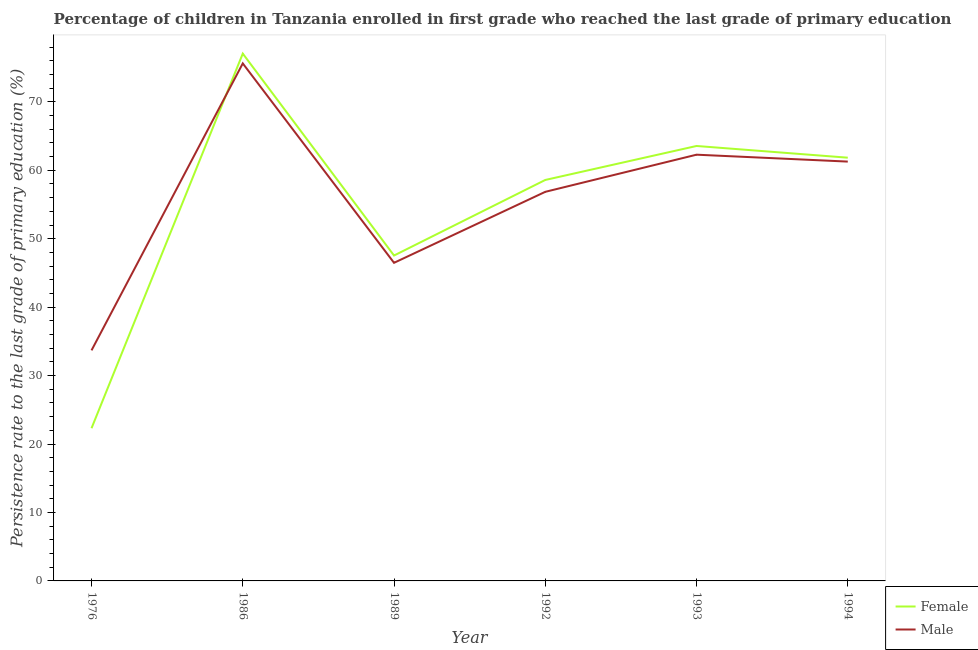Does the line corresponding to persistence rate of male students intersect with the line corresponding to persistence rate of female students?
Your answer should be very brief. Yes. What is the persistence rate of female students in 1976?
Offer a very short reply. 22.31. Across all years, what is the maximum persistence rate of female students?
Your answer should be compact. 77.05. Across all years, what is the minimum persistence rate of female students?
Offer a very short reply. 22.31. In which year was the persistence rate of female students maximum?
Offer a very short reply. 1986. In which year was the persistence rate of male students minimum?
Your answer should be compact. 1976. What is the total persistence rate of female students in the graph?
Offer a very short reply. 330.88. What is the difference between the persistence rate of male students in 1976 and that in 1992?
Provide a succinct answer. -23.16. What is the difference between the persistence rate of male students in 1986 and the persistence rate of female students in 1994?
Your answer should be very brief. 13.77. What is the average persistence rate of female students per year?
Give a very brief answer. 55.15. In the year 1976, what is the difference between the persistence rate of male students and persistence rate of female students?
Your answer should be compact. 11.38. In how many years, is the persistence rate of female students greater than 30 %?
Offer a terse response. 5. What is the ratio of the persistence rate of female students in 1986 to that in 1992?
Offer a very short reply. 1.32. Is the persistence rate of male students in 1986 less than that in 1992?
Keep it short and to the point. No. What is the difference between the highest and the second highest persistence rate of male students?
Make the answer very short. 13.34. What is the difference between the highest and the lowest persistence rate of female students?
Provide a short and direct response. 54.74. In how many years, is the persistence rate of male students greater than the average persistence rate of male students taken over all years?
Ensure brevity in your answer.  4. Is the sum of the persistence rate of male students in 1993 and 1994 greater than the maximum persistence rate of female students across all years?
Your answer should be compact. Yes. Is the persistence rate of female students strictly greater than the persistence rate of male students over the years?
Offer a terse response. No. How many lines are there?
Provide a succinct answer. 2. What is the difference between two consecutive major ticks on the Y-axis?
Your answer should be compact. 10. Are the values on the major ticks of Y-axis written in scientific E-notation?
Provide a succinct answer. No. Does the graph contain grids?
Ensure brevity in your answer.  No. Where does the legend appear in the graph?
Ensure brevity in your answer.  Bottom right. How are the legend labels stacked?
Offer a terse response. Vertical. What is the title of the graph?
Give a very brief answer. Percentage of children in Tanzania enrolled in first grade who reached the last grade of primary education. What is the label or title of the X-axis?
Provide a succinct answer. Year. What is the label or title of the Y-axis?
Give a very brief answer. Persistence rate to the last grade of primary education (%). What is the Persistence rate to the last grade of primary education (%) in Female in 1976?
Provide a short and direct response. 22.31. What is the Persistence rate to the last grade of primary education (%) in Male in 1976?
Provide a short and direct response. 33.69. What is the Persistence rate to the last grade of primary education (%) in Female in 1986?
Ensure brevity in your answer.  77.05. What is the Persistence rate to the last grade of primary education (%) of Male in 1986?
Offer a very short reply. 75.62. What is the Persistence rate to the last grade of primary education (%) in Female in 1989?
Provide a short and direct response. 47.55. What is the Persistence rate to the last grade of primary education (%) in Male in 1989?
Ensure brevity in your answer.  46.48. What is the Persistence rate to the last grade of primary education (%) in Female in 1992?
Provide a short and direct response. 58.59. What is the Persistence rate to the last grade of primary education (%) in Male in 1992?
Your response must be concise. 56.85. What is the Persistence rate to the last grade of primary education (%) of Female in 1993?
Ensure brevity in your answer.  63.55. What is the Persistence rate to the last grade of primary education (%) in Male in 1993?
Make the answer very short. 62.28. What is the Persistence rate to the last grade of primary education (%) in Female in 1994?
Make the answer very short. 61.84. What is the Persistence rate to the last grade of primary education (%) in Male in 1994?
Your response must be concise. 61.27. Across all years, what is the maximum Persistence rate to the last grade of primary education (%) in Female?
Give a very brief answer. 77.05. Across all years, what is the maximum Persistence rate to the last grade of primary education (%) of Male?
Provide a short and direct response. 75.62. Across all years, what is the minimum Persistence rate to the last grade of primary education (%) in Female?
Ensure brevity in your answer.  22.31. Across all years, what is the minimum Persistence rate to the last grade of primary education (%) of Male?
Give a very brief answer. 33.69. What is the total Persistence rate to the last grade of primary education (%) of Female in the graph?
Your answer should be very brief. 330.88. What is the total Persistence rate to the last grade of primary education (%) of Male in the graph?
Your answer should be very brief. 336.19. What is the difference between the Persistence rate to the last grade of primary education (%) in Female in 1976 and that in 1986?
Ensure brevity in your answer.  -54.74. What is the difference between the Persistence rate to the last grade of primary education (%) of Male in 1976 and that in 1986?
Your answer should be very brief. -41.93. What is the difference between the Persistence rate to the last grade of primary education (%) of Female in 1976 and that in 1989?
Your answer should be compact. -25.23. What is the difference between the Persistence rate to the last grade of primary education (%) of Male in 1976 and that in 1989?
Offer a very short reply. -12.79. What is the difference between the Persistence rate to the last grade of primary education (%) in Female in 1976 and that in 1992?
Your answer should be compact. -36.27. What is the difference between the Persistence rate to the last grade of primary education (%) of Male in 1976 and that in 1992?
Offer a terse response. -23.16. What is the difference between the Persistence rate to the last grade of primary education (%) in Female in 1976 and that in 1993?
Your response must be concise. -41.24. What is the difference between the Persistence rate to the last grade of primary education (%) of Male in 1976 and that in 1993?
Give a very brief answer. -28.59. What is the difference between the Persistence rate to the last grade of primary education (%) of Female in 1976 and that in 1994?
Keep it short and to the point. -39.53. What is the difference between the Persistence rate to the last grade of primary education (%) in Male in 1976 and that in 1994?
Give a very brief answer. -27.58. What is the difference between the Persistence rate to the last grade of primary education (%) in Female in 1986 and that in 1989?
Keep it short and to the point. 29.5. What is the difference between the Persistence rate to the last grade of primary education (%) in Male in 1986 and that in 1989?
Your answer should be very brief. 29.14. What is the difference between the Persistence rate to the last grade of primary education (%) of Female in 1986 and that in 1992?
Offer a terse response. 18.46. What is the difference between the Persistence rate to the last grade of primary education (%) of Male in 1986 and that in 1992?
Keep it short and to the point. 18.76. What is the difference between the Persistence rate to the last grade of primary education (%) of Female in 1986 and that in 1993?
Your answer should be very brief. 13.5. What is the difference between the Persistence rate to the last grade of primary education (%) in Male in 1986 and that in 1993?
Provide a succinct answer. 13.34. What is the difference between the Persistence rate to the last grade of primary education (%) of Female in 1986 and that in 1994?
Give a very brief answer. 15.21. What is the difference between the Persistence rate to the last grade of primary education (%) in Male in 1986 and that in 1994?
Give a very brief answer. 14.35. What is the difference between the Persistence rate to the last grade of primary education (%) of Female in 1989 and that in 1992?
Provide a short and direct response. -11.04. What is the difference between the Persistence rate to the last grade of primary education (%) in Male in 1989 and that in 1992?
Your answer should be compact. -10.37. What is the difference between the Persistence rate to the last grade of primary education (%) in Female in 1989 and that in 1993?
Your response must be concise. -16.01. What is the difference between the Persistence rate to the last grade of primary education (%) of Male in 1989 and that in 1993?
Provide a succinct answer. -15.8. What is the difference between the Persistence rate to the last grade of primary education (%) of Female in 1989 and that in 1994?
Your answer should be compact. -14.3. What is the difference between the Persistence rate to the last grade of primary education (%) in Male in 1989 and that in 1994?
Give a very brief answer. -14.79. What is the difference between the Persistence rate to the last grade of primary education (%) of Female in 1992 and that in 1993?
Ensure brevity in your answer.  -4.97. What is the difference between the Persistence rate to the last grade of primary education (%) of Male in 1992 and that in 1993?
Ensure brevity in your answer.  -5.43. What is the difference between the Persistence rate to the last grade of primary education (%) in Female in 1992 and that in 1994?
Provide a succinct answer. -3.25. What is the difference between the Persistence rate to the last grade of primary education (%) in Male in 1992 and that in 1994?
Provide a succinct answer. -4.42. What is the difference between the Persistence rate to the last grade of primary education (%) of Female in 1993 and that in 1994?
Offer a very short reply. 1.71. What is the difference between the Persistence rate to the last grade of primary education (%) in Male in 1993 and that in 1994?
Keep it short and to the point. 1.01. What is the difference between the Persistence rate to the last grade of primary education (%) in Female in 1976 and the Persistence rate to the last grade of primary education (%) in Male in 1986?
Ensure brevity in your answer.  -53.3. What is the difference between the Persistence rate to the last grade of primary education (%) in Female in 1976 and the Persistence rate to the last grade of primary education (%) in Male in 1989?
Provide a short and direct response. -24.17. What is the difference between the Persistence rate to the last grade of primary education (%) of Female in 1976 and the Persistence rate to the last grade of primary education (%) of Male in 1992?
Provide a succinct answer. -34.54. What is the difference between the Persistence rate to the last grade of primary education (%) in Female in 1976 and the Persistence rate to the last grade of primary education (%) in Male in 1993?
Make the answer very short. -39.97. What is the difference between the Persistence rate to the last grade of primary education (%) in Female in 1976 and the Persistence rate to the last grade of primary education (%) in Male in 1994?
Make the answer very short. -38.96. What is the difference between the Persistence rate to the last grade of primary education (%) in Female in 1986 and the Persistence rate to the last grade of primary education (%) in Male in 1989?
Provide a succinct answer. 30.57. What is the difference between the Persistence rate to the last grade of primary education (%) of Female in 1986 and the Persistence rate to the last grade of primary education (%) of Male in 1992?
Keep it short and to the point. 20.2. What is the difference between the Persistence rate to the last grade of primary education (%) in Female in 1986 and the Persistence rate to the last grade of primary education (%) in Male in 1993?
Make the answer very short. 14.77. What is the difference between the Persistence rate to the last grade of primary education (%) in Female in 1986 and the Persistence rate to the last grade of primary education (%) in Male in 1994?
Offer a very short reply. 15.78. What is the difference between the Persistence rate to the last grade of primary education (%) in Female in 1989 and the Persistence rate to the last grade of primary education (%) in Male in 1992?
Provide a succinct answer. -9.31. What is the difference between the Persistence rate to the last grade of primary education (%) in Female in 1989 and the Persistence rate to the last grade of primary education (%) in Male in 1993?
Provide a succinct answer. -14.73. What is the difference between the Persistence rate to the last grade of primary education (%) in Female in 1989 and the Persistence rate to the last grade of primary education (%) in Male in 1994?
Provide a succinct answer. -13.72. What is the difference between the Persistence rate to the last grade of primary education (%) in Female in 1992 and the Persistence rate to the last grade of primary education (%) in Male in 1993?
Provide a short and direct response. -3.69. What is the difference between the Persistence rate to the last grade of primary education (%) of Female in 1992 and the Persistence rate to the last grade of primary education (%) of Male in 1994?
Provide a succinct answer. -2.68. What is the difference between the Persistence rate to the last grade of primary education (%) of Female in 1993 and the Persistence rate to the last grade of primary education (%) of Male in 1994?
Make the answer very short. 2.28. What is the average Persistence rate to the last grade of primary education (%) of Female per year?
Your answer should be very brief. 55.15. What is the average Persistence rate to the last grade of primary education (%) of Male per year?
Ensure brevity in your answer.  56.03. In the year 1976, what is the difference between the Persistence rate to the last grade of primary education (%) in Female and Persistence rate to the last grade of primary education (%) in Male?
Offer a very short reply. -11.38. In the year 1986, what is the difference between the Persistence rate to the last grade of primary education (%) in Female and Persistence rate to the last grade of primary education (%) in Male?
Offer a very short reply. 1.43. In the year 1989, what is the difference between the Persistence rate to the last grade of primary education (%) in Female and Persistence rate to the last grade of primary education (%) in Male?
Your answer should be compact. 1.06. In the year 1992, what is the difference between the Persistence rate to the last grade of primary education (%) in Female and Persistence rate to the last grade of primary education (%) in Male?
Your response must be concise. 1.73. In the year 1993, what is the difference between the Persistence rate to the last grade of primary education (%) of Female and Persistence rate to the last grade of primary education (%) of Male?
Your response must be concise. 1.27. In the year 1994, what is the difference between the Persistence rate to the last grade of primary education (%) of Female and Persistence rate to the last grade of primary education (%) of Male?
Keep it short and to the point. 0.57. What is the ratio of the Persistence rate to the last grade of primary education (%) in Female in 1976 to that in 1986?
Give a very brief answer. 0.29. What is the ratio of the Persistence rate to the last grade of primary education (%) in Male in 1976 to that in 1986?
Offer a very short reply. 0.45. What is the ratio of the Persistence rate to the last grade of primary education (%) of Female in 1976 to that in 1989?
Make the answer very short. 0.47. What is the ratio of the Persistence rate to the last grade of primary education (%) of Male in 1976 to that in 1989?
Offer a very short reply. 0.72. What is the ratio of the Persistence rate to the last grade of primary education (%) of Female in 1976 to that in 1992?
Offer a terse response. 0.38. What is the ratio of the Persistence rate to the last grade of primary education (%) of Male in 1976 to that in 1992?
Your answer should be compact. 0.59. What is the ratio of the Persistence rate to the last grade of primary education (%) in Female in 1976 to that in 1993?
Your response must be concise. 0.35. What is the ratio of the Persistence rate to the last grade of primary education (%) of Male in 1976 to that in 1993?
Ensure brevity in your answer.  0.54. What is the ratio of the Persistence rate to the last grade of primary education (%) in Female in 1976 to that in 1994?
Ensure brevity in your answer.  0.36. What is the ratio of the Persistence rate to the last grade of primary education (%) in Male in 1976 to that in 1994?
Give a very brief answer. 0.55. What is the ratio of the Persistence rate to the last grade of primary education (%) of Female in 1986 to that in 1989?
Your answer should be very brief. 1.62. What is the ratio of the Persistence rate to the last grade of primary education (%) in Male in 1986 to that in 1989?
Provide a succinct answer. 1.63. What is the ratio of the Persistence rate to the last grade of primary education (%) in Female in 1986 to that in 1992?
Your answer should be compact. 1.32. What is the ratio of the Persistence rate to the last grade of primary education (%) in Male in 1986 to that in 1992?
Keep it short and to the point. 1.33. What is the ratio of the Persistence rate to the last grade of primary education (%) in Female in 1986 to that in 1993?
Your answer should be compact. 1.21. What is the ratio of the Persistence rate to the last grade of primary education (%) in Male in 1986 to that in 1993?
Your answer should be very brief. 1.21. What is the ratio of the Persistence rate to the last grade of primary education (%) in Female in 1986 to that in 1994?
Make the answer very short. 1.25. What is the ratio of the Persistence rate to the last grade of primary education (%) in Male in 1986 to that in 1994?
Your answer should be compact. 1.23. What is the ratio of the Persistence rate to the last grade of primary education (%) of Female in 1989 to that in 1992?
Ensure brevity in your answer.  0.81. What is the ratio of the Persistence rate to the last grade of primary education (%) of Male in 1989 to that in 1992?
Make the answer very short. 0.82. What is the ratio of the Persistence rate to the last grade of primary education (%) of Female in 1989 to that in 1993?
Offer a very short reply. 0.75. What is the ratio of the Persistence rate to the last grade of primary education (%) in Male in 1989 to that in 1993?
Your answer should be very brief. 0.75. What is the ratio of the Persistence rate to the last grade of primary education (%) in Female in 1989 to that in 1994?
Provide a short and direct response. 0.77. What is the ratio of the Persistence rate to the last grade of primary education (%) in Male in 1989 to that in 1994?
Keep it short and to the point. 0.76. What is the ratio of the Persistence rate to the last grade of primary education (%) in Female in 1992 to that in 1993?
Your response must be concise. 0.92. What is the ratio of the Persistence rate to the last grade of primary education (%) of Male in 1992 to that in 1993?
Ensure brevity in your answer.  0.91. What is the ratio of the Persistence rate to the last grade of primary education (%) of Female in 1992 to that in 1994?
Offer a terse response. 0.95. What is the ratio of the Persistence rate to the last grade of primary education (%) of Male in 1992 to that in 1994?
Your answer should be very brief. 0.93. What is the ratio of the Persistence rate to the last grade of primary education (%) of Female in 1993 to that in 1994?
Provide a succinct answer. 1.03. What is the ratio of the Persistence rate to the last grade of primary education (%) in Male in 1993 to that in 1994?
Keep it short and to the point. 1.02. What is the difference between the highest and the second highest Persistence rate to the last grade of primary education (%) of Female?
Make the answer very short. 13.5. What is the difference between the highest and the second highest Persistence rate to the last grade of primary education (%) in Male?
Your answer should be compact. 13.34. What is the difference between the highest and the lowest Persistence rate to the last grade of primary education (%) in Female?
Make the answer very short. 54.74. What is the difference between the highest and the lowest Persistence rate to the last grade of primary education (%) in Male?
Your answer should be compact. 41.93. 